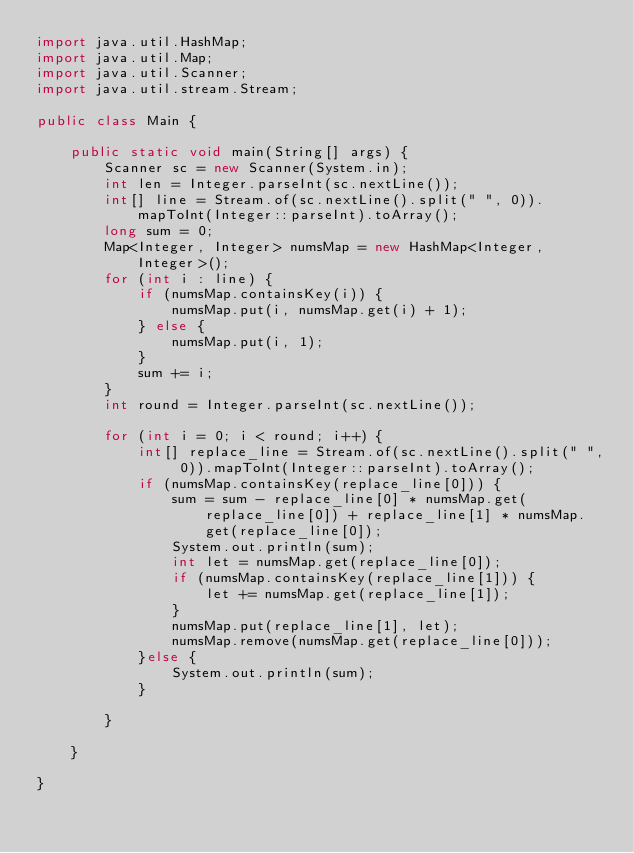Convert code to text. <code><loc_0><loc_0><loc_500><loc_500><_Java_>import java.util.HashMap;
import java.util.Map;
import java.util.Scanner;
import java.util.stream.Stream;

public class Main {

	public static void main(String[] args) {
		Scanner sc = new Scanner(System.in);
		int len = Integer.parseInt(sc.nextLine());
		int[] line = Stream.of(sc.nextLine().split(" ", 0)).mapToInt(Integer::parseInt).toArray();
		long sum = 0;
		Map<Integer, Integer> numsMap = new HashMap<Integer, Integer>();
		for (int i : line) {
			if (numsMap.containsKey(i)) {
				numsMap.put(i, numsMap.get(i) + 1);
			} else {
				numsMap.put(i, 1);
			}
			sum += i;
		}
		int round = Integer.parseInt(sc.nextLine());

		for (int i = 0; i < round; i++) {
			int[] replace_line = Stream.of(sc.nextLine().split(" ", 0)).mapToInt(Integer::parseInt).toArray();
			if (numsMap.containsKey(replace_line[0])) {
				sum = sum - replace_line[0] * numsMap.get(replace_line[0]) + replace_line[1] * numsMap.get(replace_line[0]);
				System.out.println(sum);
				int let = numsMap.get(replace_line[0]);
				if (numsMap.containsKey(replace_line[1])) {
					let += numsMap.get(replace_line[1]);
				}
				numsMap.put(replace_line[1], let);
				numsMap.remove(numsMap.get(replace_line[0]));
			}else {
				System.out.println(sum);
			}

		}

	}

}</code> 